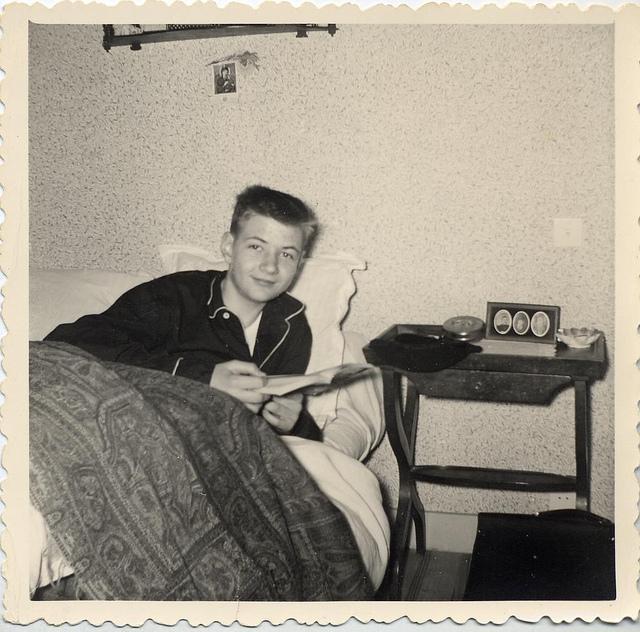How many beds can you see?
Give a very brief answer. 2. 